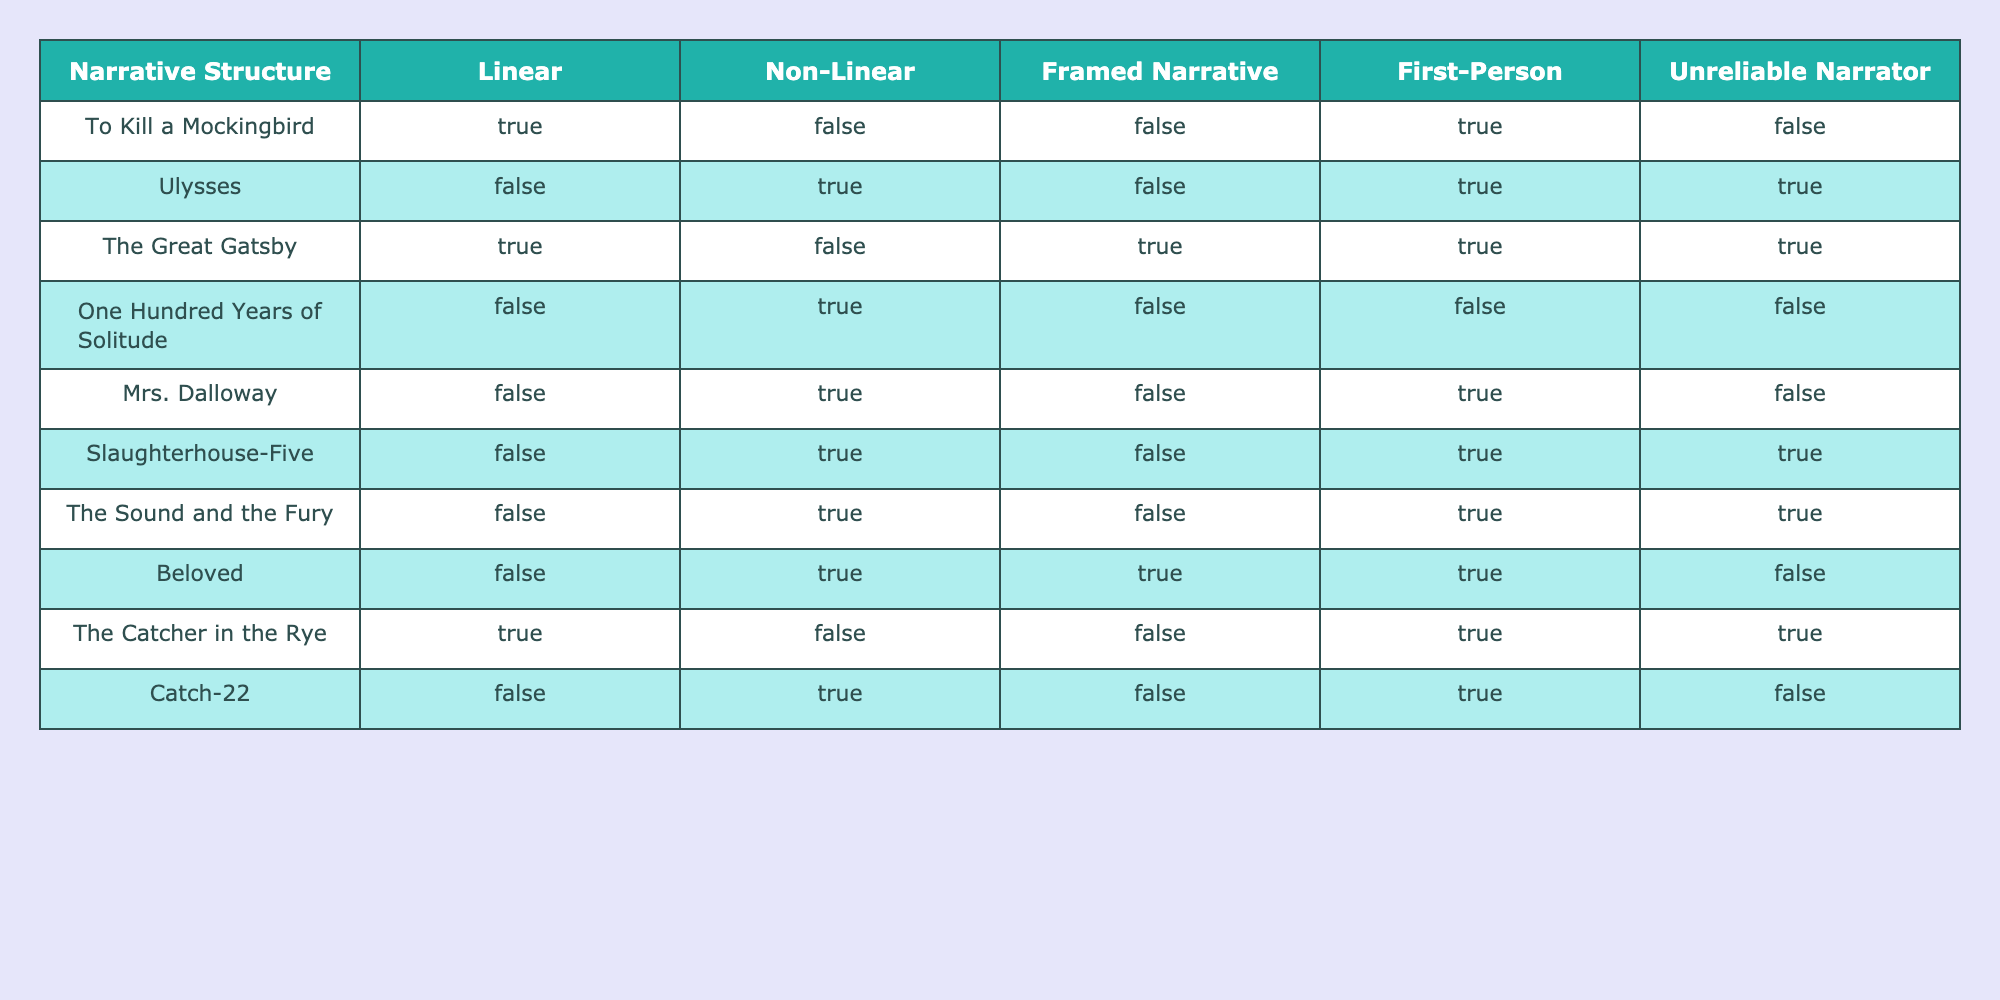What narrative structure is used in "To Kill a Mockingbird"? "To Kill a Mockingbird" has a linear narrative structure, as indicated by the TRUE value in the Linear column.
Answer: Linear Which novels use a non-linear narrative structure? The novels that employ a non-linear narrative structure are "Ulysses", "One Hundred Years of Solitude", "Mrs. Dalloway", "Slaughterhouse-Five", "The Sound and the Fury", and "Catch-22". There are 6 such novels.
Answer: 6 Is "The Great Gatsby" an example of a framed narrative? "The Great Gatsby" has a TRUE value for the Framed Narrative column, meaning it does indeed use a framed narrative structure.
Answer: Yes How many novels in the list are written in first-person perspective? There are 6 novels that utilize the first-person narrative: "To Kill a Mockingbird", "Ulysses", "The Great Gatsby", "Slaughterhouse-Five", "The Catcher in the Rye", and "Catch-22".
Answer: 6 Which novel is both non-linear and includes an unreliable narrator? The novels that are both non-linear and contain an unreliable narrator are "Ulysses", "Slaughterhouse-Five", and "The Sound and the Fury". Each of these has TRUE values in both the Non-Linear and Unreliable Narrator columns.
Answer: 3 How many novels do not have an unreliable narrator? The novels that do not have an unreliable narrator are "To Kill a Mockingbird", "One Hundred Years of Solitude", "Mrs. Dalloway", "The Great Gatsby", and "Catch-22". This gives us 5 novels without an unreliable narrator.
Answer: 5 Which novel is the only one to have both a framed narrative and be a linear narrative? "The Great Gatsby" is the only novel that features both a linear narrative structure (TRUE) and a framed narrative (TRUE).
Answer: "The Great Gatsby" Are there any novels that are both non-linear and framed narratives? "Beloved" is the only novel that is both non-linear (TRUE in the Non-Linear column) and has a framed narrative (TRUE in the Framed Narrative column).
Answer: No 